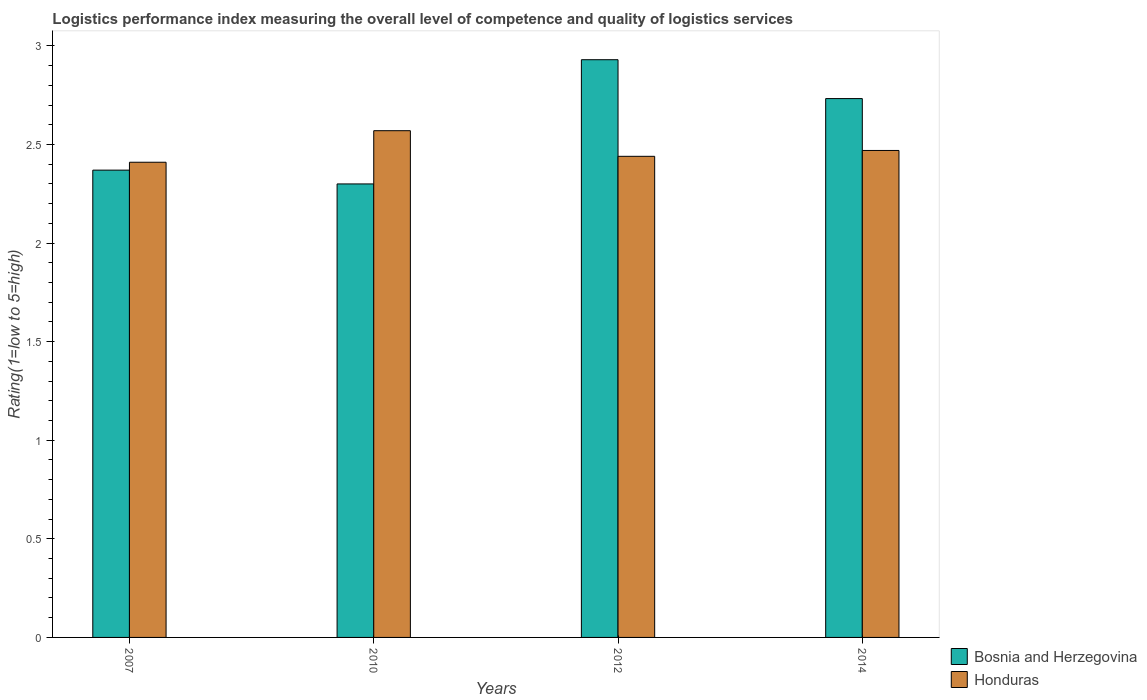Are the number of bars per tick equal to the number of legend labels?
Offer a terse response. Yes. How many bars are there on the 4th tick from the right?
Offer a terse response. 2. What is the label of the 1st group of bars from the left?
Your response must be concise. 2007. In how many cases, is the number of bars for a given year not equal to the number of legend labels?
Ensure brevity in your answer.  0. What is the Logistic performance index in Bosnia and Herzegovina in 2014?
Offer a terse response. 2.73. Across all years, what is the maximum Logistic performance index in Bosnia and Herzegovina?
Ensure brevity in your answer.  2.93. Across all years, what is the minimum Logistic performance index in Honduras?
Your answer should be very brief. 2.41. What is the total Logistic performance index in Bosnia and Herzegovina in the graph?
Your answer should be very brief. 10.33. What is the difference between the Logistic performance index in Bosnia and Herzegovina in 2007 and that in 2012?
Offer a terse response. -0.56. What is the difference between the Logistic performance index in Bosnia and Herzegovina in 2007 and the Logistic performance index in Honduras in 2012?
Give a very brief answer. -0.07. What is the average Logistic performance index in Honduras per year?
Your answer should be very brief. 2.47. In the year 2012, what is the difference between the Logistic performance index in Bosnia and Herzegovina and Logistic performance index in Honduras?
Give a very brief answer. 0.49. In how many years, is the Logistic performance index in Bosnia and Herzegovina greater than 1.4?
Ensure brevity in your answer.  4. What is the ratio of the Logistic performance index in Honduras in 2007 to that in 2012?
Offer a very short reply. 0.99. Is the difference between the Logistic performance index in Bosnia and Herzegovina in 2007 and 2010 greater than the difference between the Logistic performance index in Honduras in 2007 and 2010?
Keep it short and to the point. Yes. What is the difference between the highest and the second highest Logistic performance index in Honduras?
Your response must be concise. 0.1. What is the difference between the highest and the lowest Logistic performance index in Honduras?
Your answer should be compact. 0.16. In how many years, is the Logistic performance index in Bosnia and Herzegovina greater than the average Logistic performance index in Bosnia and Herzegovina taken over all years?
Your response must be concise. 2. What does the 2nd bar from the left in 2012 represents?
Your answer should be very brief. Honduras. What does the 1st bar from the right in 2007 represents?
Keep it short and to the point. Honduras. How many bars are there?
Give a very brief answer. 8. Are all the bars in the graph horizontal?
Offer a very short reply. No. Where does the legend appear in the graph?
Make the answer very short. Bottom right. How many legend labels are there?
Your answer should be compact. 2. How are the legend labels stacked?
Your answer should be very brief. Vertical. What is the title of the graph?
Your answer should be very brief. Logistics performance index measuring the overall level of competence and quality of logistics services. Does "Colombia" appear as one of the legend labels in the graph?
Ensure brevity in your answer.  No. What is the label or title of the Y-axis?
Provide a succinct answer. Rating(1=low to 5=high). What is the Rating(1=low to 5=high) of Bosnia and Herzegovina in 2007?
Make the answer very short. 2.37. What is the Rating(1=low to 5=high) in Honduras in 2007?
Give a very brief answer. 2.41. What is the Rating(1=low to 5=high) of Bosnia and Herzegovina in 2010?
Offer a terse response. 2.3. What is the Rating(1=low to 5=high) in Honduras in 2010?
Your answer should be very brief. 2.57. What is the Rating(1=low to 5=high) of Bosnia and Herzegovina in 2012?
Ensure brevity in your answer.  2.93. What is the Rating(1=low to 5=high) in Honduras in 2012?
Provide a succinct answer. 2.44. What is the Rating(1=low to 5=high) in Bosnia and Herzegovina in 2014?
Provide a short and direct response. 2.73. What is the Rating(1=low to 5=high) of Honduras in 2014?
Give a very brief answer. 2.47. Across all years, what is the maximum Rating(1=low to 5=high) in Bosnia and Herzegovina?
Ensure brevity in your answer.  2.93. Across all years, what is the maximum Rating(1=low to 5=high) in Honduras?
Your answer should be compact. 2.57. Across all years, what is the minimum Rating(1=low to 5=high) of Honduras?
Give a very brief answer. 2.41. What is the total Rating(1=low to 5=high) of Bosnia and Herzegovina in the graph?
Keep it short and to the point. 10.33. What is the total Rating(1=low to 5=high) in Honduras in the graph?
Offer a very short reply. 9.89. What is the difference between the Rating(1=low to 5=high) of Bosnia and Herzegovina in 2007 and that in 2010?
Offer a very short reply. 0.07. What is the difference between the Rating(1=low to 5=high) in Honduras in 2007 and that in 2010?
Make the answer very short. -0.16. What is the difference between the Rating(1=low to 5=high) in Bosnia and Herzegovina in 2007 and that in 2012?
Offer a very short reply. -0.56. What is the difference between the Rating(1=low to 5=high) of Honduras in 2007 and that in 2012?
Give a very brief answer. -0.03. What is the difference between the Rating(1=low to 5=high) of Bosnia and Herzegovina in 2007 and that in 2014?
Your answer should be very brief. -0.36. What is the difference between the Rating(1=low to 5=high) in Honduras in 2007 and that in 2014?
Ensure brevity in your answer.  -0.06. What is the difference between the Rating(1=low to 5=high) in Bosnia and Herzegovina in 2010 and that in 2012?
Provide a short and direct response. -0.63. What is the difference between the Rating(1=low to 5=high) of Honduras in 2010 and that in 2012?
Keep it short and to the point. 0.13. What is the difference between the Rating(1=low to 5=high) of Bosnia and Herzegovina in 2010 and that in 2014?
Your answer should be compact. -0.43. What is the difference between the Rating(1=low to 5=high) in Honduras in 2010 and that in 2014?
Ensure brevity in your answer.  0.1. What is the difference between the Rating(1=low to 5=high) in Bosnia and Herzegovina in 2012 and that in 2014?
Your answer should be very brief. 0.2. What is the difference between the Rating(1=low to 5=high) in Honduras in 2012 and that in 2014?
Provide a succinct answer. -0.03. What is the difference between the Rating(1=low to 5=high) in Bosnia and Herzegovina in 2007 and the Rating(1=low to 5=high) in Honduras in 2010?
Offer a very short reply. -0.2. What is the difference between the Rating(1=low to 5=high) of Bosnia and Herzegovina in 2007 and the Rating(1=low to 5=high) of Honduras in 2012?
Provide a short and direct response. -0.07. What is the difference between the Rating(1=low to 5=high) in Bosnia and Herzegovina in 2007 and the Rating(1=low to 5=high) in Honduras in 2014?
Provide a short and direct response. -0.1. What is the difference between the Rating(1=low to 5=high) in Bosnia and Herzegovina in 2010 and the Rating(1=low to 5=high) in Honduras in 2012?
Your answer should be very brief. -0.14. What is the difference between the Rating(1=low to 5=high) in Bosnia and Herzegovina in 2010 and the Rating(1=low to 5=high) in Honduras in 2014?
Make the answer very short. -0.17. What is the difference between the Rating(1=low to 5=high) of Bosnia and Herzegovina in 2012 and the Rating(1=low to 5=high) of Honduras in 2014?
Provide a succinct answer. 0.46. What is the average Rating(1=low to 5=high) in Bosnia and Herzegovina per year?
Make the answer very short. 2.58. What is the average Rating(1=low to 5=high) in Honduras per year?
Provide a short and direct response. 2.47. In the year 2007, what is the difference between the Rating(1=low to 5=high) in Bosnia and Herzegovina and Rating(1=low to 5=high) in Honduras?
Give a very brief answer. -0.04. In the year 2010, what is the difference between the Rating(1=low to 5=high) in Bosnia and Herzegovina and Rating(1=low to 5=high) in Honduras?
Your answer should be very brief. -0.27. In the year 2012, what is the difference between the Rating(1=low to 5=high) in Bosnia and Herzegovina and Rating(1=low to 5=high) in Honduras?
Your answer should be compact. 0.49. In the year 2014, what is the difference between the Rating(1=low to 5=high) in Bosnia and Herzegovina and Rating(1=low to 5=high) in Honduras?
Provide a short and direct response. 0.26. What is the ratio of the Rating(1=low to 5=high) in Bosnia and Herzegovina in 2007 to that in 2010?
Provide a short and direct response. 1.03. What is the ratio of the Rating(1=low to 5=high) in Honduras in 2007 to that in 2010?
Keep it short and to the point. 0.94. What is the ratio of the Rating(1=low to 5=high) of Bosnia and Herzegovina in 2007 to that in 2012?
Offer a very short reply. 0.81. What is the ratio of the Rating(1=low to 5=high) in Honduras in 2007 to that in 2012?
Make the answer very short. 0.99. What is the ratio of the Rating(1=low to 5=high) in Bosnia and Herzegovina in 2007 to that in 2014?
Provide a short and direct response. 0.87. What is the ratio of the Rating(1=low to 5=high) of Honduras in 2007 to that in 2014?
Your answer should be very brief. 0.98. What is the ratio of the Rating(1=low to 5=high) in Bosnia and Herzegovina in 2010 to that in 2012?
Your response must be concise. 0.79. What is the ratio of the Rating(1=low to 5=high) of Honduras in 2010 to that in 2012?
Your answer should be compact. 1.05. What is the ratio of the Rating(1=low to 5=high) in Bosnia and Herzegovina in 2010 to that in 2014?
Provide a succinct answer. 0.84. What is the ratio of the Rating(1=low to 5=high) in Honduras in 2010 to that in 2014?
Offer a very short reply. 1.04. What is the ratio of the Rating(1=low to 5=high) in Bosnia and Herzegovina in 2012 to that in 2014?
Your response must be concise. 1.07. What is the ratio of the Rating(1=low to 5=high) of Honduras in 2012 to that in 2014?
Keep it short and to the point. 0.99. What is the difference between the highest and the second highest Rating(1=low to 5=high) of Bosnia and Herzegovina?
Provide a succinct answer. 0.2. What is the difference between the highest and the second highest Rating(1=low to 5=high) of Honduras?
Offer a very short reply. 0.1. What is the difference between the highest and the lowest Rating(1=low to 5=high) of Bosnia and Herzegovina?
Offer a very short reply. 0.63. What is the difference between the highest and the lowest Rating(1=low to 5=high) in Honduras?
Offer a terse response. 0.16. 